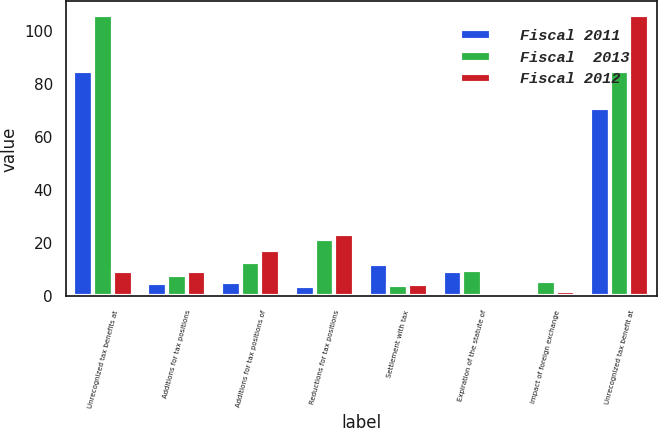Convert chart. <chart><loc_0><loc_0><loc_500><loc_500><stacked_bar_chart><ecel><fcel>Unrecognized tax benefits at<fcel>Additions for tax positions<fcel>Additions for tax positions of<fcel>Reductions for tax positions<fcel>Settlement with tax<fcel>Expiration of the statute of<fcel>Impact of foreign exchange<fcel>Unrecognized tax benefit at<nl><fcel>Fiscal 2011<fcel>84.7<fcel>5<fcel>5.3<fcel>3.7<fcel>12<fcel>9.7<fcel>1.1<fcel>70.7<nl><fcel>Fiscal  2013<fcel>105.7<fcel>8<fcel>13<fcel>21.6<fcel>4.2<fcel>9.8<fcel>5.6<fcel>84.7<nl><fcel>Fiscal 2012<fcel>9.7<fcel>9.7<fcel>17.3<fcel>23.3<fcel>4.5<fcel>0.4<fcel>2.1<fcel>105.7<nl></chart> 